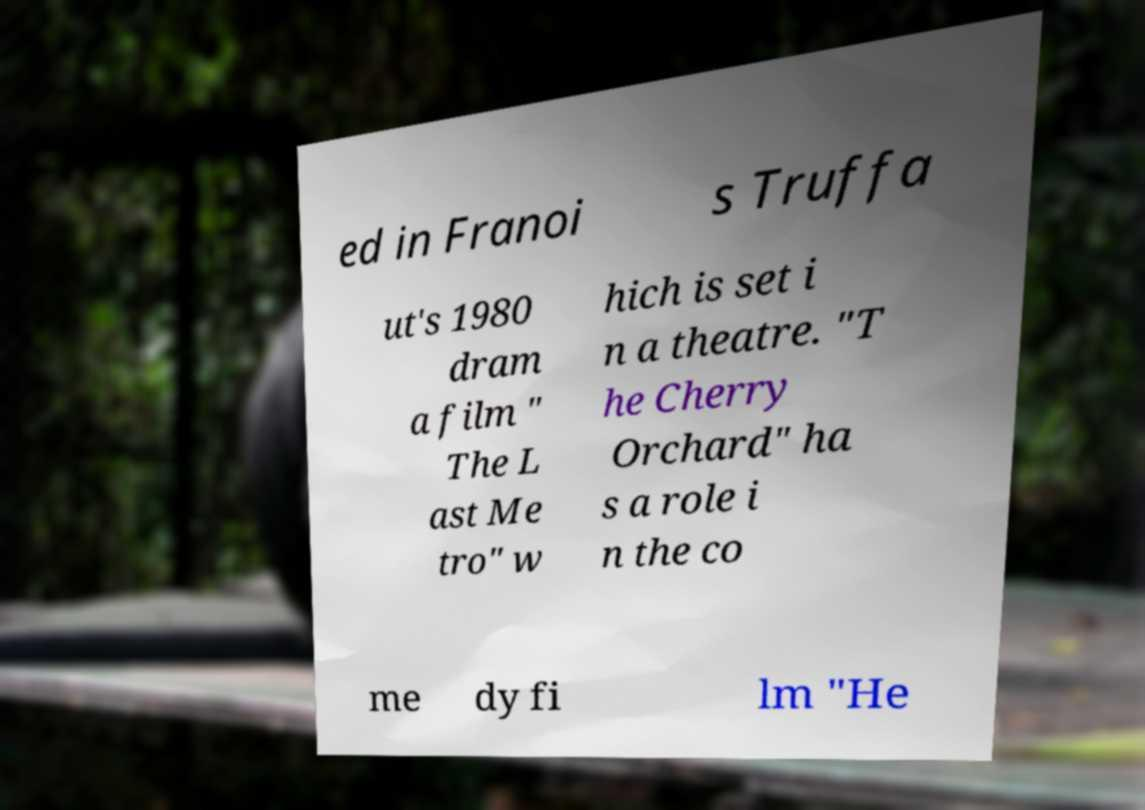Please identify and transcribe the text found in this image. ed in Franoi s Truffa ut's 1980 dram a film " The L ast Me tro" w hich is set i n a theatre. "T he Cherry Orchard" ha s a role i n the co me dy fi lm "He 